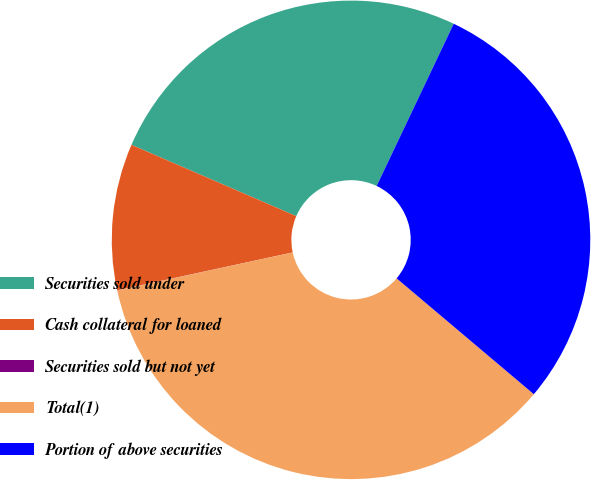<chart> <loc_0><loc_0><loc_500><loc_500><pie_chart><fcel>Securities sold under<fcel>Cash collateral for loaned<fcel>Securities sold but not yet<fcel>Total(1)<fcel>Portion of above securities<nl><fcel>25.56%<fcel>9.88%<fcel>0.01%<fcel>35.45%<fcel>29.1%<nl></chart> 